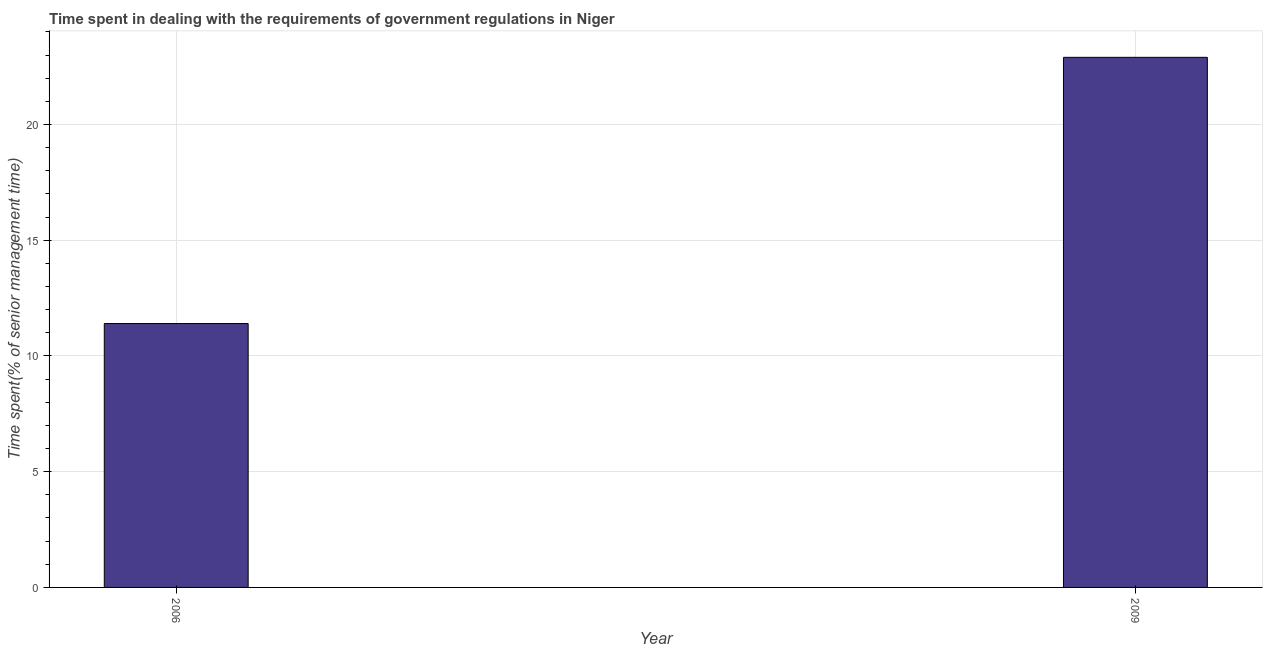What is the title of the graph?
Make the answer very short. Time spent in dealing with the requirements of government regulations in Niger. What is the label or title of the X-axis?
Offer a terse response. Year. What is the label or title of the Y-axis?
Make the answer very short. Time spent(% of senior management time). What is the time spent in dealing with government regulations in 2009?
Your answer should be compact. 22.9. Across all years, what is the maximum time spent in dealing with government regulations?
Your response must be concise. 22.9. Across all years, what is the minimum time spent in dealing with government regulations?
Your response must be concise. 11.4. In which year was the time spent in dealing with government regulations maximum?
Your response must be concise. 2009. What is the sum of the time spent in dealing with government regulations?
Give a very brief answer. 34.3. What is the average time spent in dealing with government regulations per year?
Keep it short and to the point. 17.15. What is the median time spent in dealing with government regulations?
Your answer should be compact. 17.15. In how many years, is the time spent in dealing with government regulations greater than 11 %?
Offer a terse response. 2. Do a majority of the years between 2009 and 2006 (inclusive) have time spent in dealing with government regulations greater than 17 %?
Provide a succinct answer. No. What is the ratio of the time spent in dealing with government regulations in 2006 to that in 2009?
Your response must be concise. 0.5. How many years are there in the graph?
Your answer should be compact. 2. Are the values on the major ticks of Y-axis written in scientific E-notation?
Give a very brief answer. No. What is the Time spent(% of senior management time) in 2009?
Provide a short and direct response. 22.9. What is the difference between the Time spent(% of senior management time) in 2006 and 2009?
Keep it short and to the point. -11.5. What is the ratio of the Time spent(% of senior management time) in 2006 to that in 2009?
Make the answer very short. 0.5. 